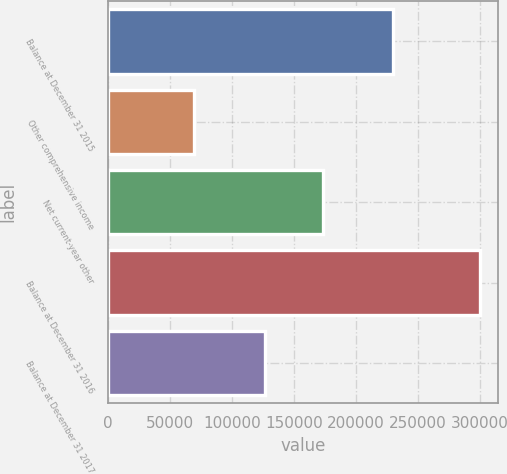<chart> <loc_0><loc_0><loc_500><loc_500><bar_chart><fcel>Balance at December 31 2015<fcel>Other comprehensive income<fcel>Net current-year other<fcel>Balance at December 31 2016<fcel>Balance at December 31 2017<nl><fcel>229746<fcel>69119<fcel>173074<fcel>299697<fcel>126623<nl></chart> 